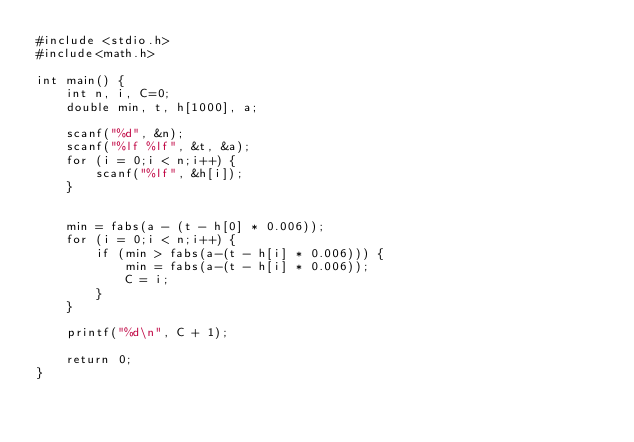<code> <loc_0><loc_0><loc_500><loc_500><_C_>#include <stdio.h>
#include<math.h>

int main() {
	int n, i, C=0;
	double min, t, h[1000], a;

	scanf("%d", &n);
	scanf("%lf %lf", &t, &a);
	for (i = 0;i < n;i++) {
		scanf("%lf", &h[i]);
	}


	min = fabs(a - (t - h[0] * 0.006));
	for (i = 0;i < n;i++) {
		if (min > fabs(a-(t - h[i] * 0.006))) {
			min = fabs(a-(t - h[i] * 0.006));
			C = i;
		}
	}

	printf("%d\n", C + 1);

	return 0;
}</code> 